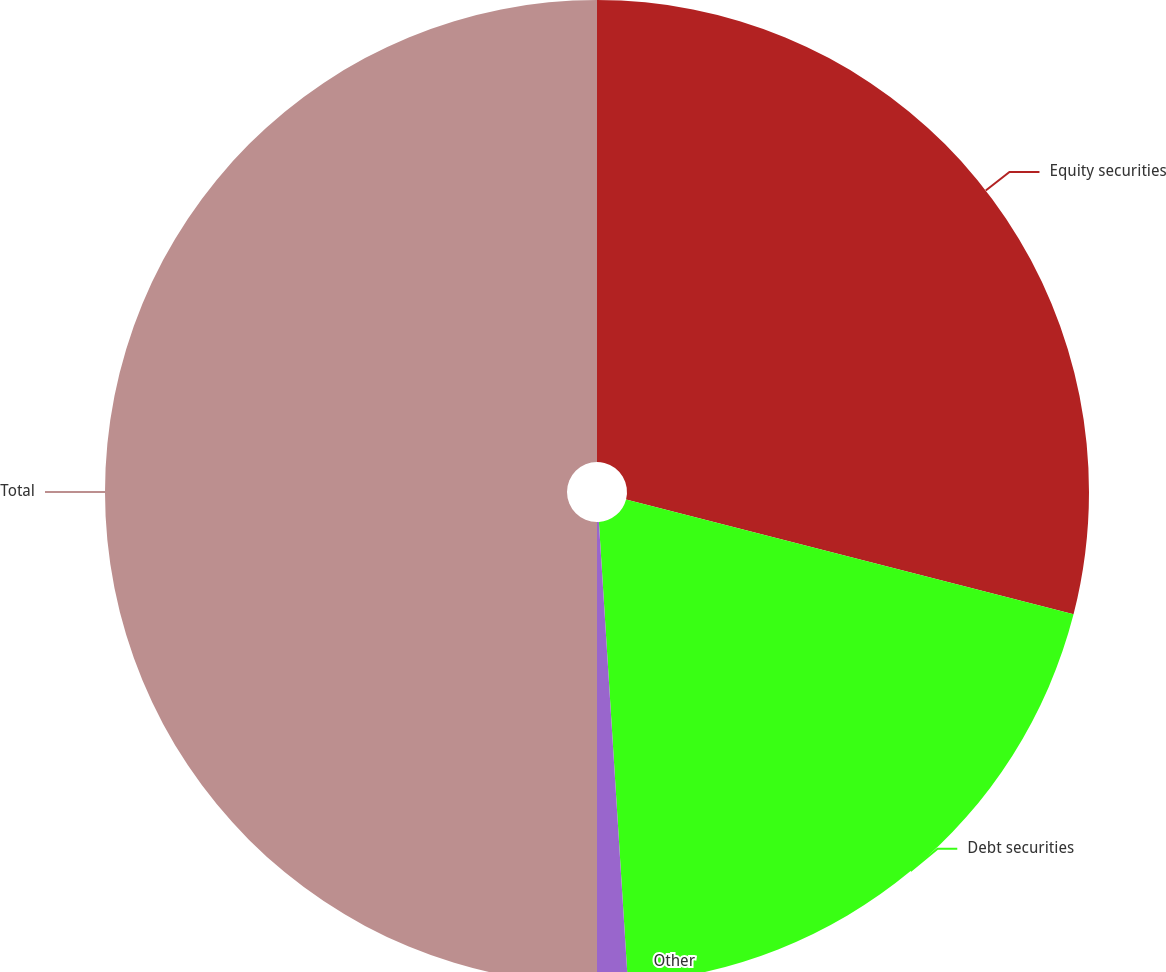Convert chart to OTSL. <chart><loc_0><loc_0><loc_500><loc_500><pie_chart><fcel>Equity securities<fcel>Debt securities<fcel>Other<fcel>Total<nl><fcel>29.0%<fcel>20.0%<fcel>1.0%<fcel>50.0%<nl></chart> 